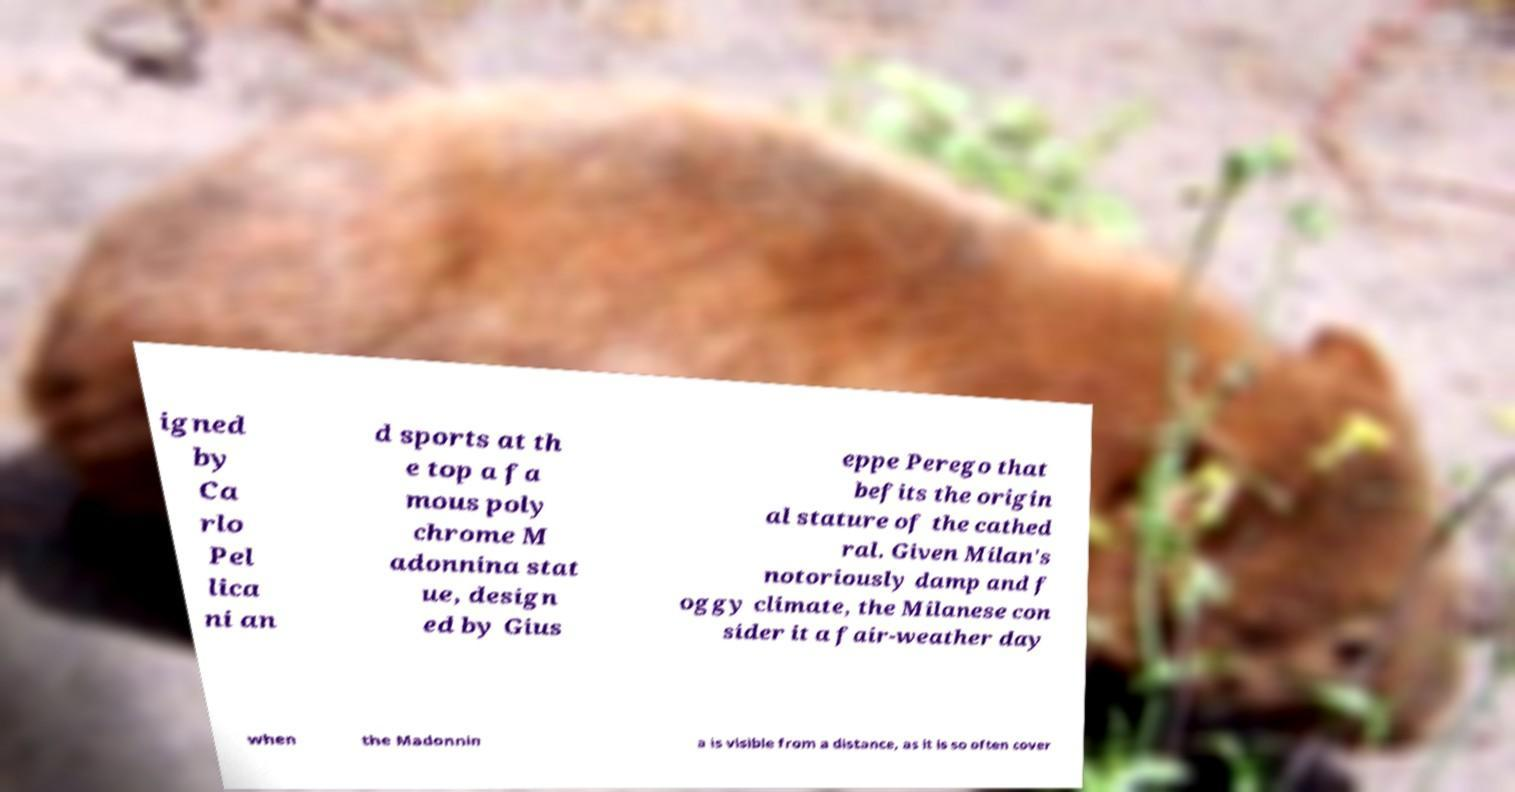Could you extract and type out the text from this image? igned by Ca rlo Pel lica ni an d sports at th e top a fa mous poly chrome M adonnina stat ue, design ed by Gius eppe Perego that befits the origin al stature of the cathed ral. Given Milan's notoriously damp and f oggy climate, the Milanese con sider it a fair-weather day when the Madonnin a is visible from a distance, as it is so often cover 